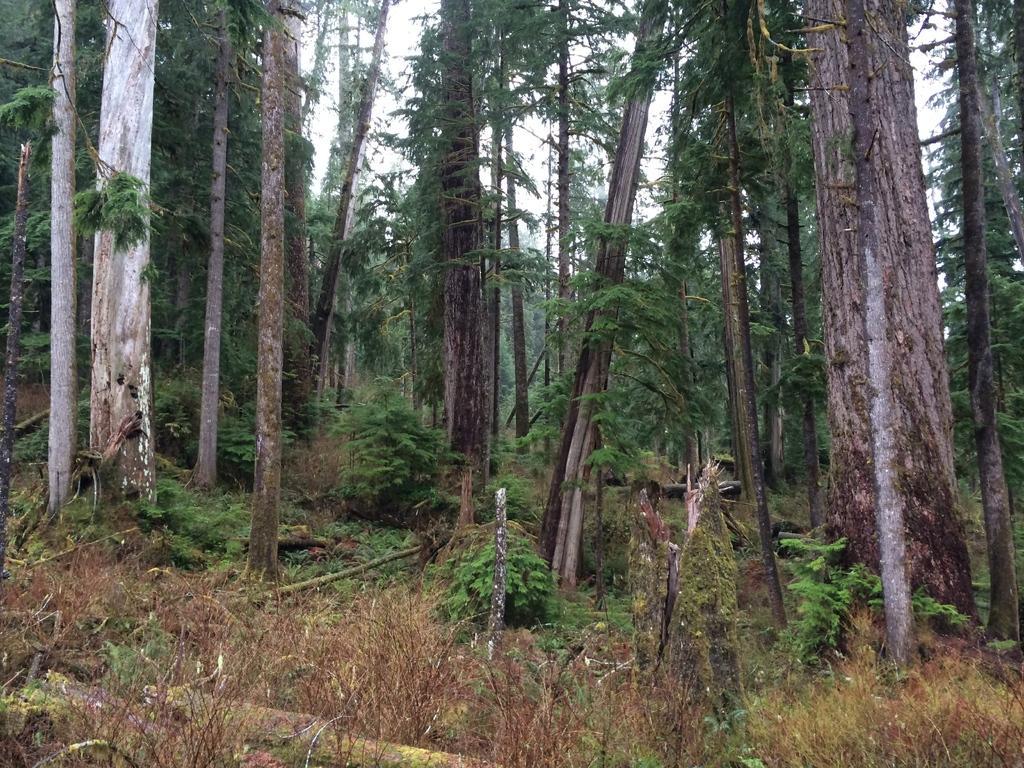Please provide a concise description of this image. In this image we can see many trees. On the ground there are plants and logs. In the background there is sky. 